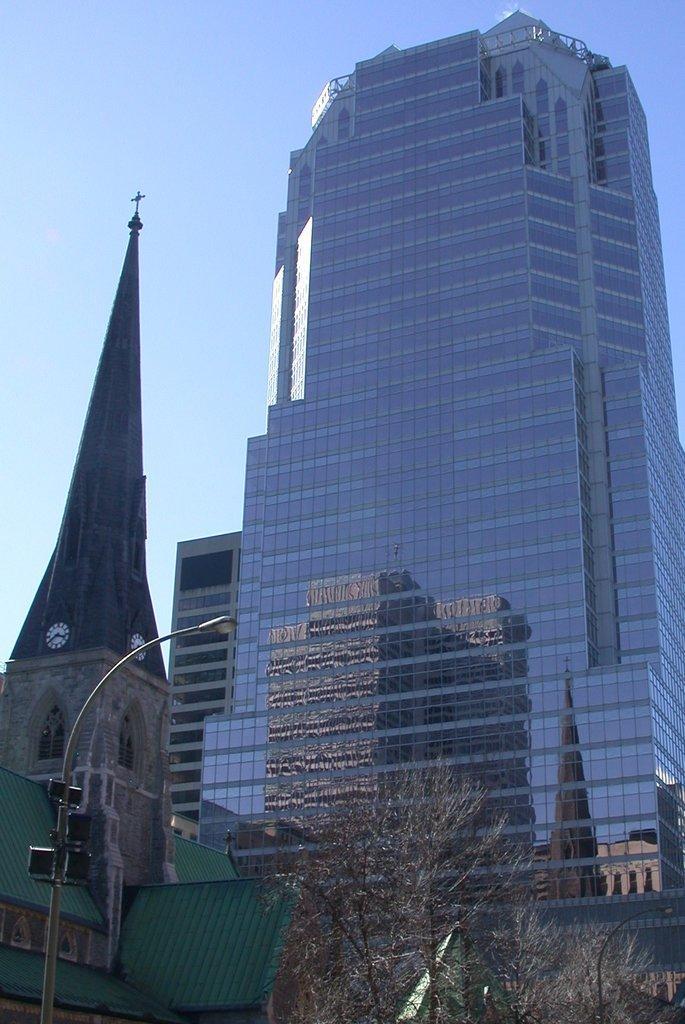Could you give a brief overview of what you see in this image? In this picture we can see light pole, trees and buildings. In the background of the image we can see the sky. 